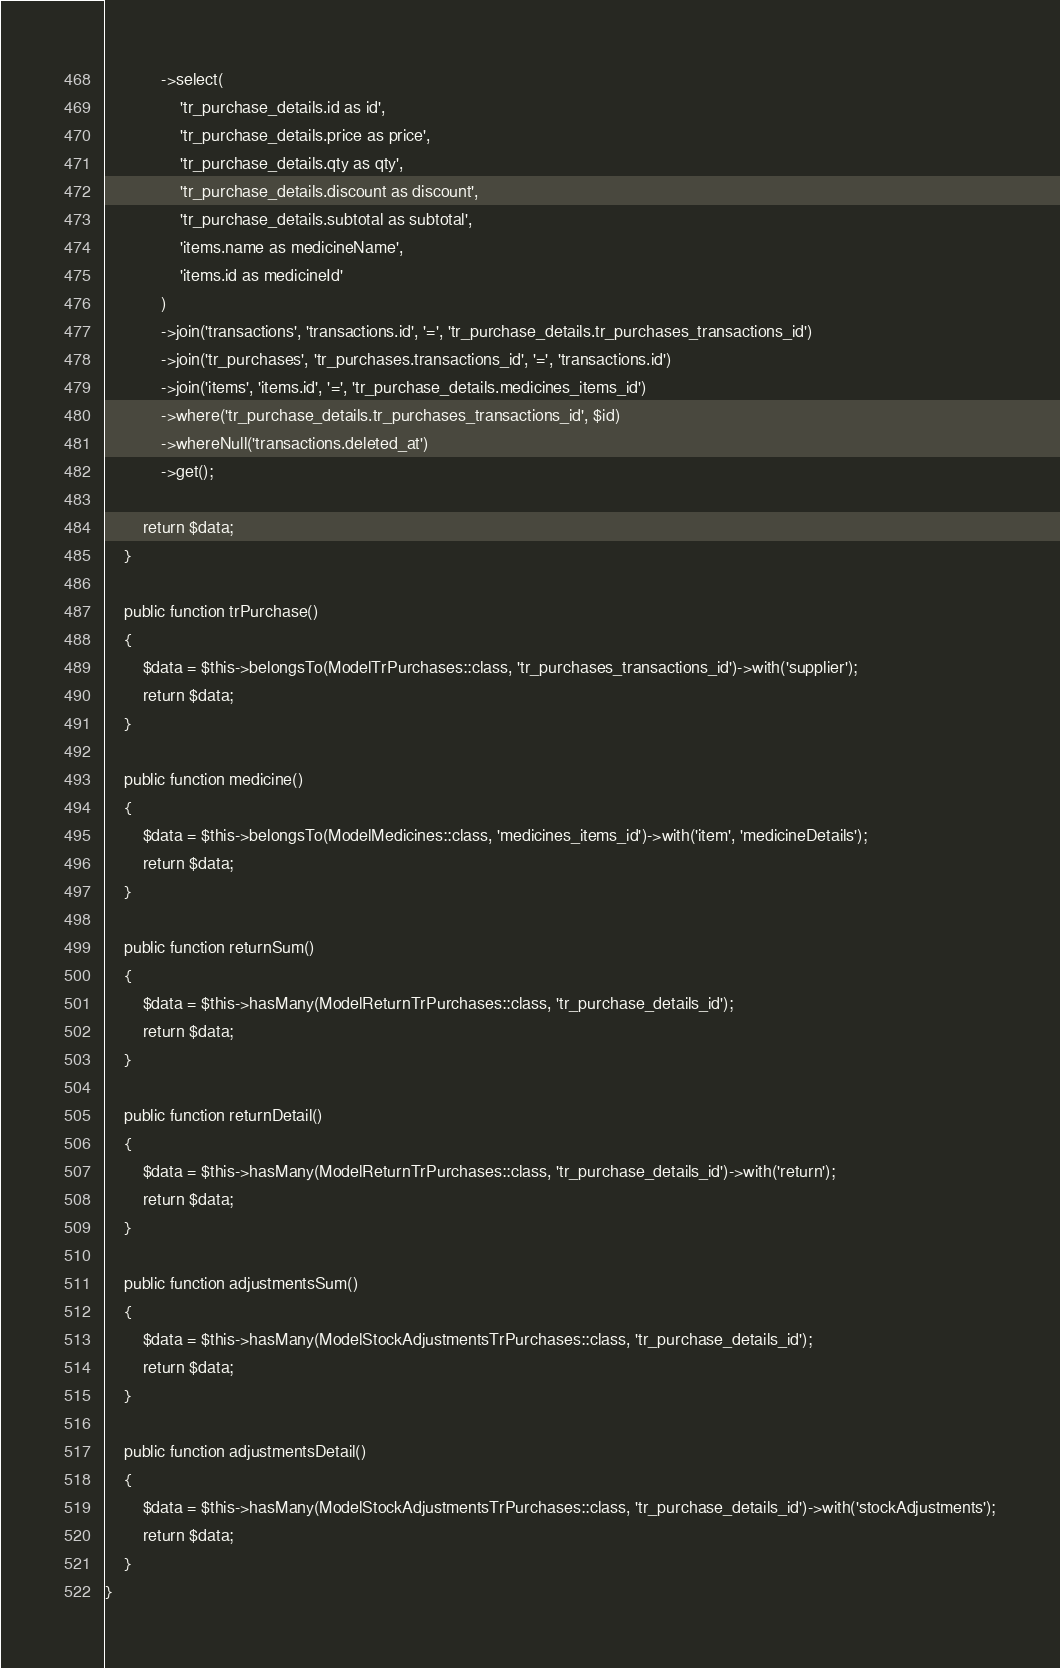<code> <loc_0><loc_0><loc_500><loc_500><_PHP_>            ->select(
                'tr_purchase_details.id as id',
                'tr_purchase_details.price as price',
                'tr_purchase_details.qty as qty',
                'tr_purchase_details.discount as discount',
                'tr_purchase_details.subtotal as subtotal',
                'items.name as medicineName',
                'items.id as medicineId'
            )
            ->join('transactions', 'transactions.id', '=', 'tr_purchase_details.tr_purchases_transactions_id')
            ->join('tr_purchases', 'tr_purchases.transactions_id', '=', 'transactions.id')
            ->join('items', 'items.id', '=', 'tr_purchase_details.medicines_items_id')
            ->where('tr_purchase_details.tr_purchases_transactions_id', $id)
            ->whereNull('transactions.deleted_at')
            ->get();

        return $data;
    }

    public function trPurchase()
    {
        $data = $this->belongsTo(ModelTrPurchases::class, 'tr_purchases_transactions_id')->with('supplier');
        return $data;
    }

    public function medicine()
    {
        $data = $this->belongsTo(ModelMedicines::class, 'medicines_items_id')->with('item', 'medicineDetails');
        return $data;
    }

    public function returnSum()
    {
        $data = $this->hasMany(ModelReturnTrPurchases::class, 'tr_purchase_details_id');
        return $data;
    }

    public function returnDetail()
    {
        $data = $this->hasMany(ModelReturnTrPurchases::class, 'tr_purchase_details_id')->with('return');
        return $data;
    }

    public function adjustmentsSum()
    {
        $data = $this->hasMany(ModelStockAdjustmentsTrPurchases::class, 'tr_purchase_details_id');
        return $data;
    }

    public function adjustmentsDetail()
    {
        $data = $this->hasMany(ModelStockAdjustmentsTrPurchases::class, 'tr_purchase_details_id')->with('stockAdjustments');
        return $data;
    }
}
</code> 